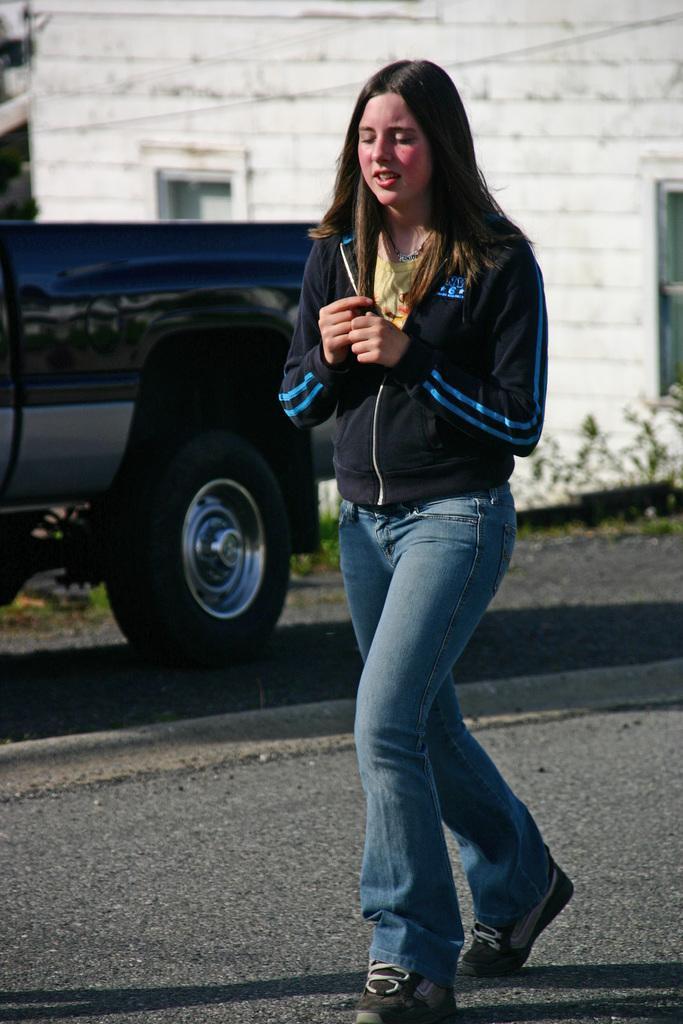How would you summarize this image in a sentence or two? In this image I can see a person wearing black jacket, blue pant. Background I can see a vehicle and building in white color. 